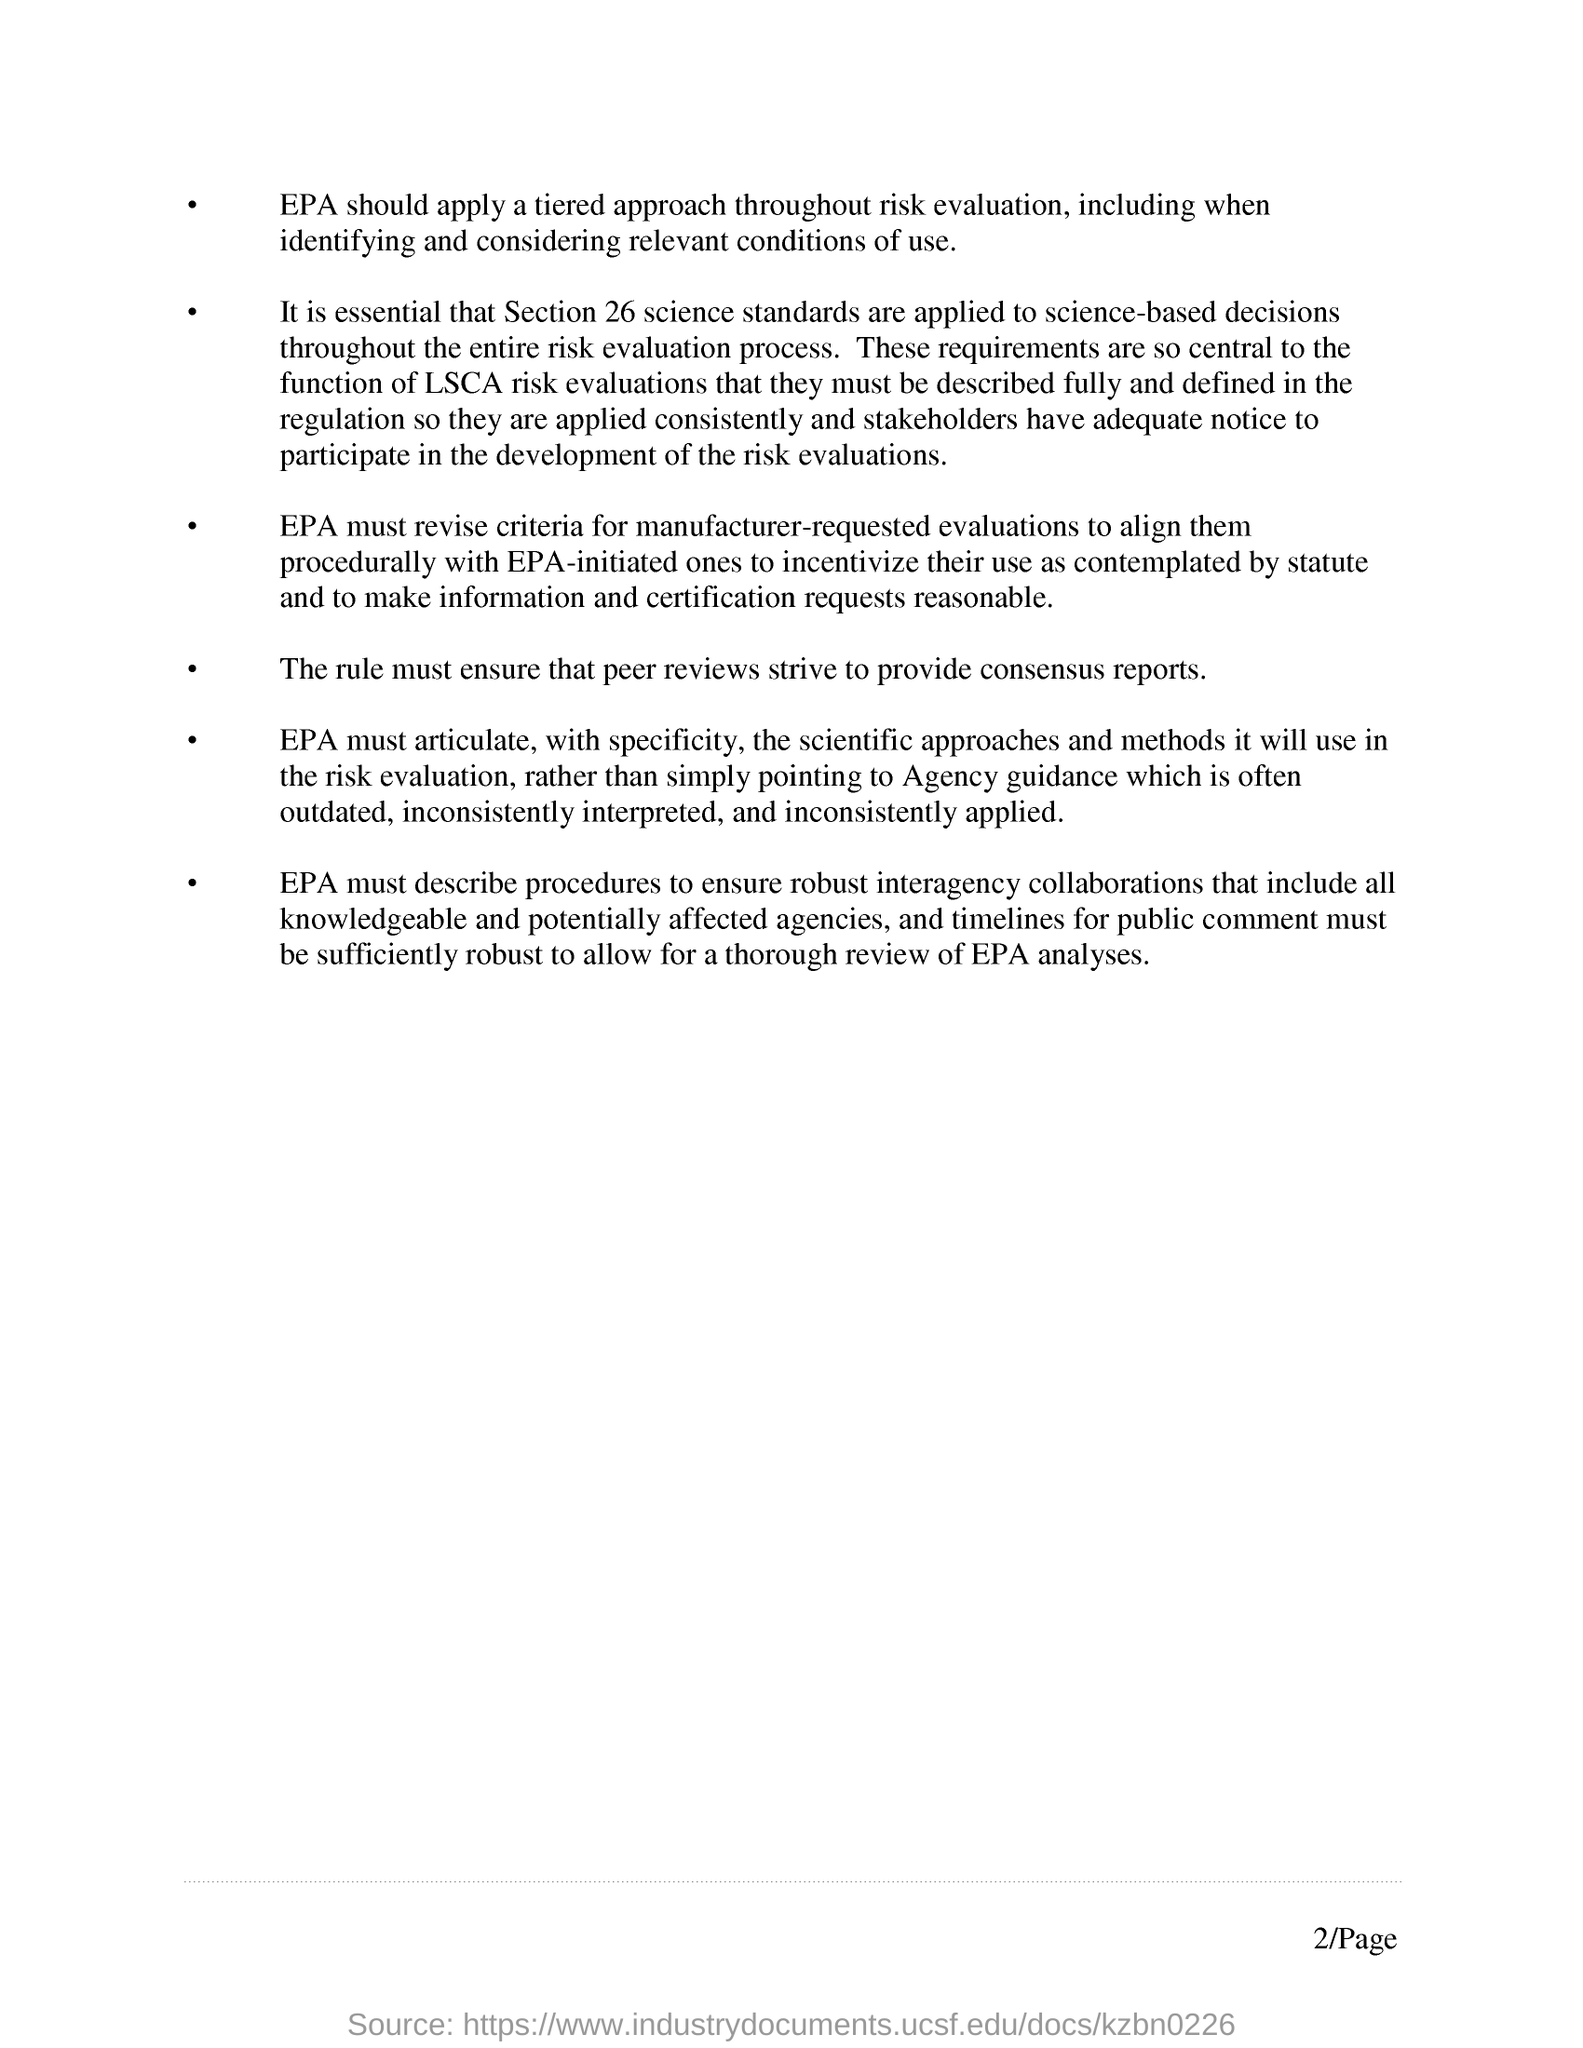Identify some key points in this picture. What page number is mentioned in this document? 